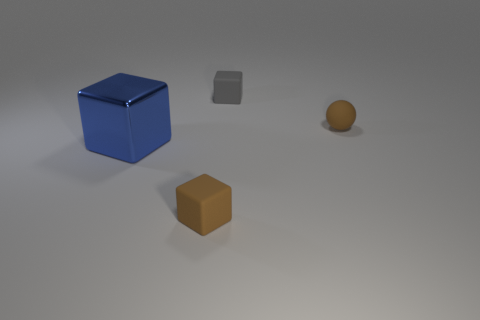Add 2 tiny blocks. How many objects exist? 6 Subtract all blocks. How many objects are left? 1 Subtract 0 yellow balls. How many objects are left? 4 Subtract all tiny brown rubber spheres. Subtract all large things. How many objects are left? 2 Add 2 blue metallic things. How many blue metallic things are left? 3 Add 4 matte spheres. How many matte spheres exist? 5 